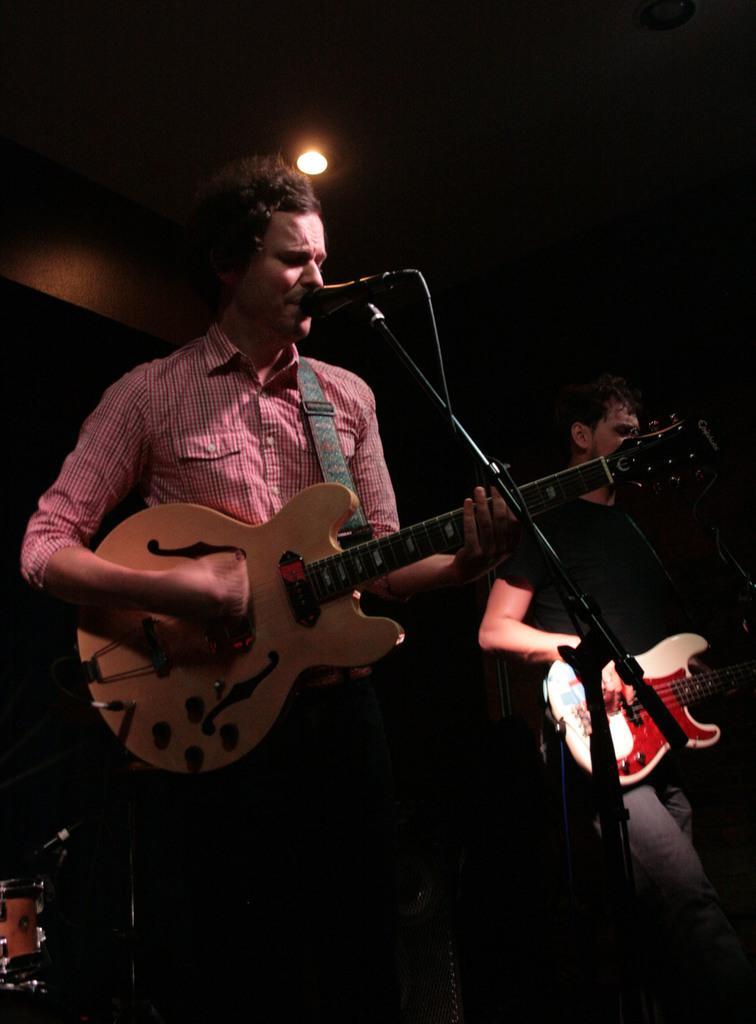Please provide a concise description of this image. The person wearing pink shirt is playing guitar and singing in front of a mic and the person beside him is playing guitar. 